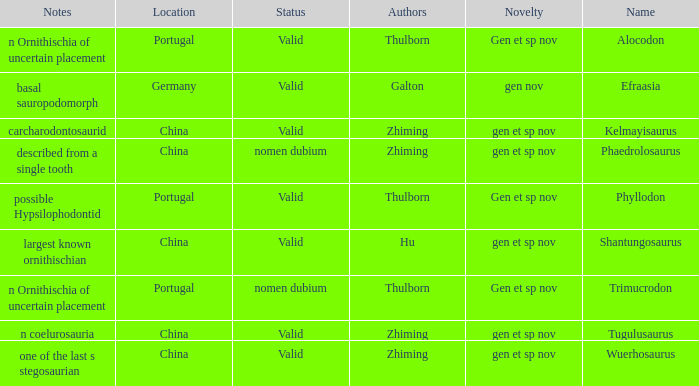Parse the table in full. {'header': ['Notes', 'Location', 'Status', 'Authors', 'Novelty', 'Name'], 'rows': [['n Ornithischia of uncertain placement', 'Portugal', 'Valid', 'Thulborn', 'Gen et sp nov', 'Alocodon'], ['basal sauropodomorph', 'Germany', 'Valid', 'Galton', 'gen nov', 'Efraasia'], ['carcharodontosaurid', 'China', 'Valid', 'Zhiming', 'gen et sp nov', 'Kelmayisaurus'], ['described from a single tooth', 'China', 'nomen dubium', 'Zhiming', 'gen et sp nov', 'Phaedrolosaurus'], ['possible Hypsilophodontid', 'Portugal', 'Valid', 'Thulborn', 'Gen et sp nov', 'Phyllodon'], ['largest known ornithischian', 'China', 'Valid', 'Hu', 'gen et sp nov', 'Shantungosaurus'], ['n Ornithischia of uncertain placement', 'Portugal', 'nomen dubium', 'Thulborn', 'Gen et sp nov', 'Trimucrodon'], ['n coelurosauria', 'China', 'Valid', 'Zhiming', 'gen et sp nov', 'Tugulusaurus'], ['one of the last s stegosaurian', 'China', 'Valid', 'Zhiming', 'gen et sp nov', 'Wuerhosaurus']]} What is the Status of the dinosaur, whose notes are, "n coelurosauria"? Valid. 